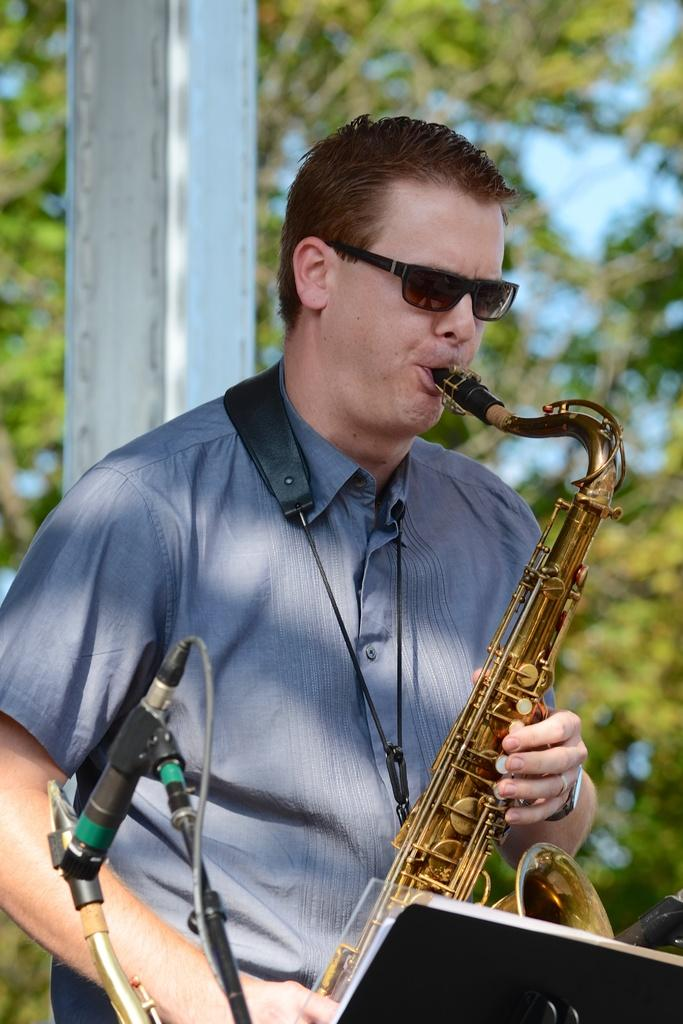What is the man in the image doing? The man is playing a music instrument in the image. What might the man be using to read music while playing? There is a music notation stand in front of the man. How is the background of the image depicted? The background of the man is blurred. What type of vest is the man wearing in the image? There is no mention of a vest in the image, so it cannot be determined what type of vest the man might be wearing. 